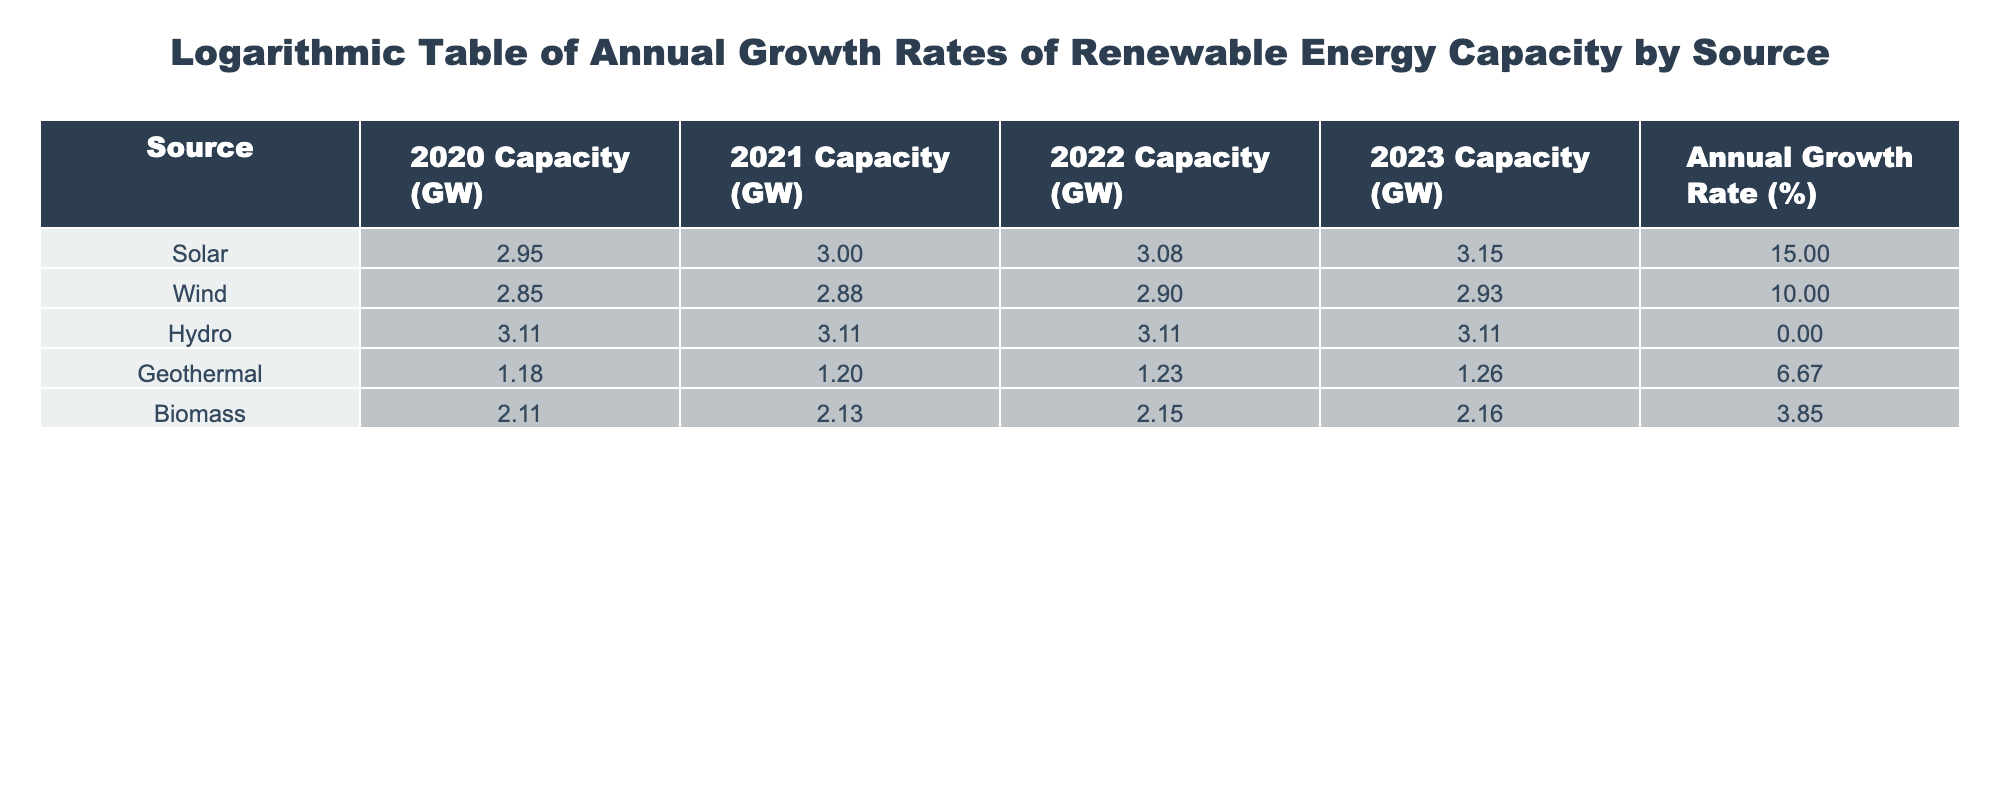What is the annual growth rate for solar energy capacity? The table directly lists the annual growth rates by source. For solar energy, the corresponding value is stated as 15%.
Answer: 15% Which energy source has the highest annual growth rate? By comparing the annual growth rates listed for each source, solar energy is at 15%, which is greater than all other sources.
Answer: Solar What was the capacity of hydro energy in 2023? The table specifies the capacity for hydro in 2023, which is recorded as 1300 GW.
Answer: 1300 GW Calculate the average annual growth rate for all sources except hydro. First, identify the growth rates of the remaining sources: solar (15%), wind (10%), geothermal (6.67%), and biomass (3.85%). Then, sum these values: 15 + 10 + 6.67 + 3.85 = 35.52. Finally, divide by the number of sources (4) to get the average: 35.52 / 4 = 8.88.
Answer: 8.88% Is the annual growth rate for geothermal energy greater than that for biomass? The growth rates for geothermal and biomass are 6.67% and 3.85%, respectively. Since 6.67% is greater than 3.85%, the statement is true.
Answer: Yes What is the difference between the 2020 capacity of solar and wind energy? Looking at the respective values for solar (900 GW) and wind (700 GW) in 2020, the difference can be calculated as 900 - 700 = 200 GW.
Answer: 200 GW Which energy source maintained a constant capacity from 2020 to 2023? From the table, hydro energy is shown to have a constant capacity of 1300 GW across the years 2020, 2021, 2022, and 2023, confirming this observation.
Answer: Hydro Which renewable energy sources have an annual growth rate greater than 5%? Referring to the table, the sources with growth rates exceeding 5% are solar (15%), wind (10%), and geothermal (6.67%). Biomass has a rate of 3.85%, which is below 5%.
Answer: Solar, Wind, Geothermal Was there any decline in capacity for any of the energy sources from 2020 to 2023? According to the table, all energy sources either maintained or increased their capacity over the years, as hydro is constant, and others show positive growth. Therefore, there was no decline.
Answer: No 